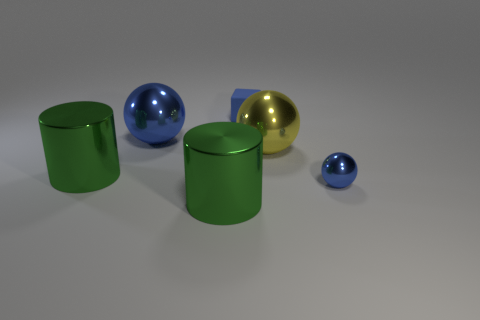Are there any metal spheres that are in front of the big ball that is to the left of the large yellow metal thing?
Make the answer very short. Yes. There is another small thing that is the same shape as the yellow shiny thing; what is its material?
Provide a succinct answer. Metal. What number of tiny objects are to the left of the tiny blue object behind the tiny blue sphere?
Give a very brief answer. 0. Are there any other things of the same color as the tiny metal sphere?
Offer a terse response. Yes. How many things are small yellow shiny blocks or blue things that are to the left of the tiny blue block?
Your answer should be compact. 1. The blue ball to the right of the green metallic thing that is right of the metal ball to the left of the tiny blue block is made of what material?
Make the answer very short. Metal. There is a yellow ball that is made of the same material as the big blue sphere; what is its size?
Ensure brevity in your answer.  Large. What is the color of the large cylinder in front of the tiny blue thing on the right side of the blue matte thing?
Ensure brevity in your answer.  Green. What number of big green cylinders have the same material as the big yellow thing?
Your answer should be compact. 2. How many matte objects are big blue objects or tiny objects?
Offer a terse response. 1. 